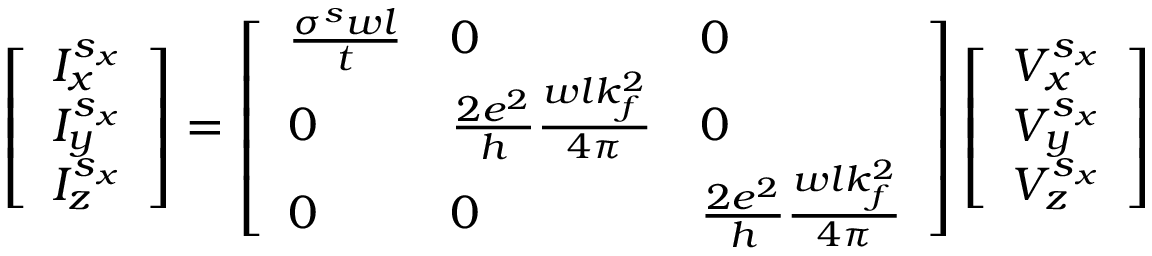<formula> <loc_0><loc_0><loc_500><loc_500>\left [ \begin{array} { l } { I _ { x } ^ { s _ { x } } } \\ { I _ { y } ^ { s _ { x } } } \\ { I _ { z } ^ { s _ { x } } } \end{array} \right ] = \left [ \begin{array} { l l l } { \frac { \sigma ^ { s } w l } { t } } & { 0 } & { 0 } \\ { 0 } & { \frac { 2 e ^ { 2 } } { h } \frac { w l k _ { f } ^ { 2 } } { 4 \pi } } & { 0 } \\ { 0 } & { 0 } & { \frac { 2 e ^ { 2 } } { h } \frac { w l k _ { f } ^ { 2 } } { 4 \pi } } \end{array} \right ] \left [ \begin{array} { l } { V _ { x } ^ { s _ { x } } } \\ { V _ { y } ^ { s _ { x } } } \\ { V _ { z } ^ { s _ { x } } } \end{array} \right ]</formula> 